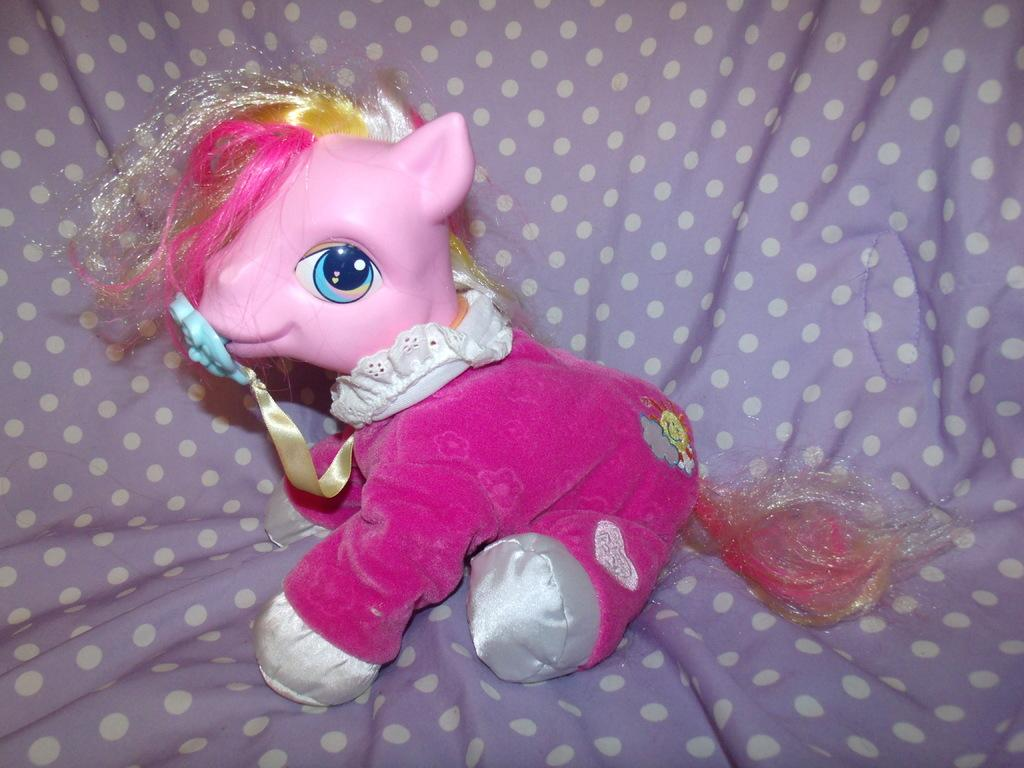What object can be seen in the image? There is a toy in the image. Where is the toy located? The toy is on a blanket. What type of plant is growing on the chair in the image? There is no plant or chair present in the image; it only features a toy on a blanket. 